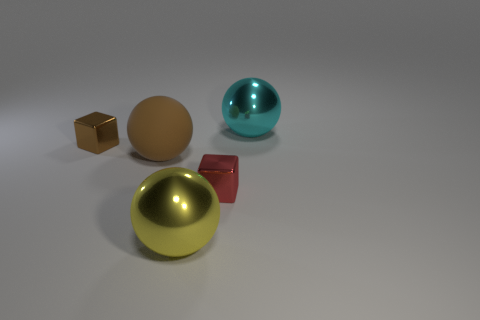Can you tell me more about the textures and characteristics of the objects in the image? Certainly! The objects in the image exhibit different textures and finishes. The cube is a matte gold, suggesting a non-reflective, possibly painted surface. The large sphere has a polished, reflective metal look. The small shiny block has a mirror-like finish, reflecting its environment, while the red object looks like smooth matte plastic. Lastly, the yellow metal object at the forefront has a shiny, reflective gold surface indicative of polished metal. 